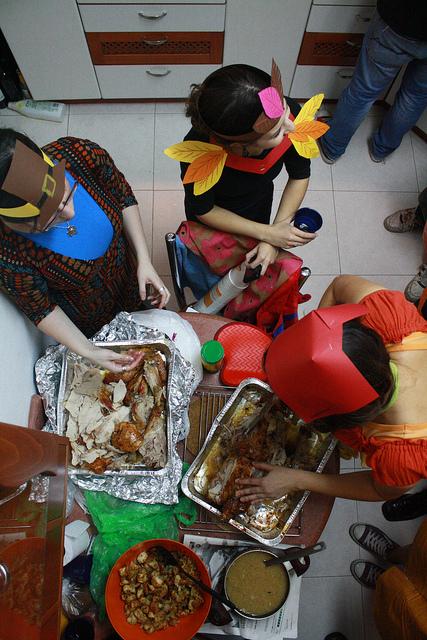Could these children be dressed like "Pilgrims"?
Concise answer only. Yes. Is this picture taken from below or above?
Give a very brief answer. Above. What kind of food is there?
Quick response, please. Turkey. 